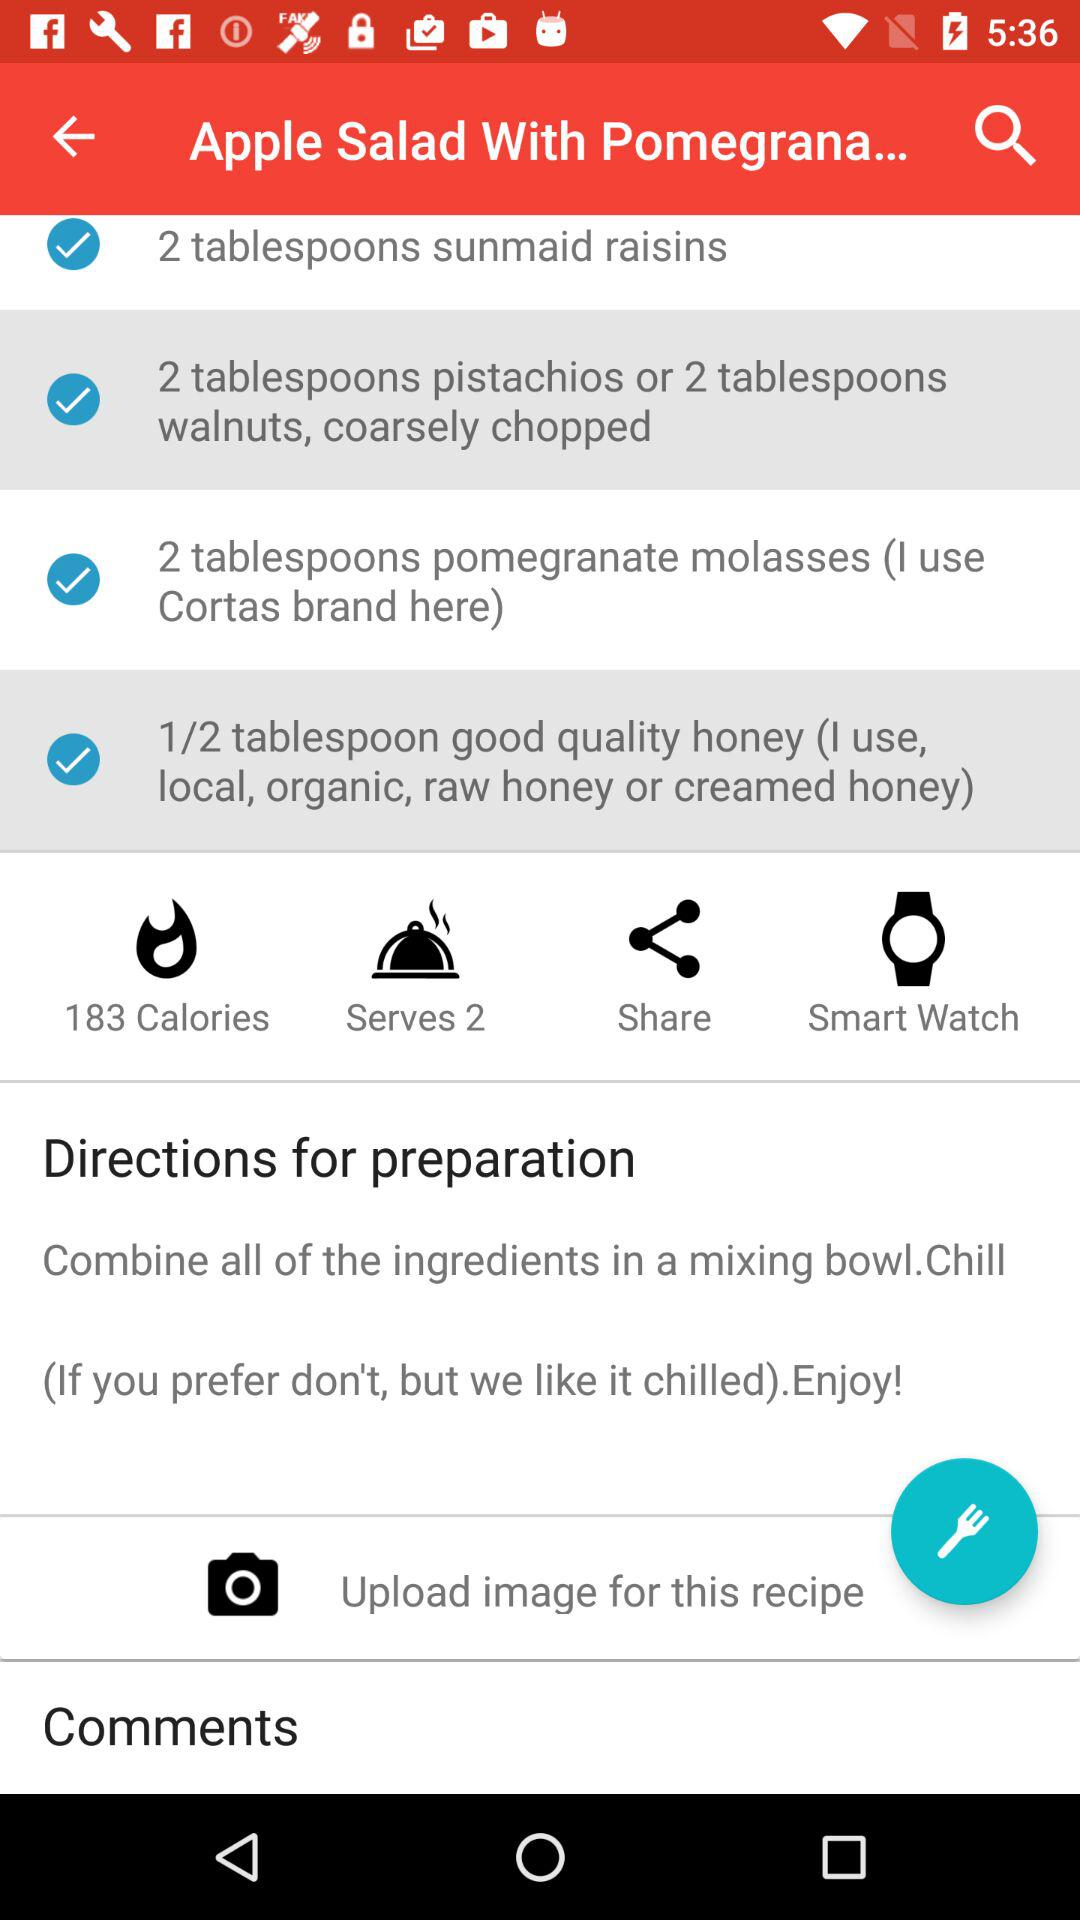What are the names of the ingredients of "Apple Salad With Pomegranate..."? The ingredients of "Apple Salad With Pomegranate..." are "raisins", "pistachios", "walnuts", "pomegranate molasses" and "honey". 